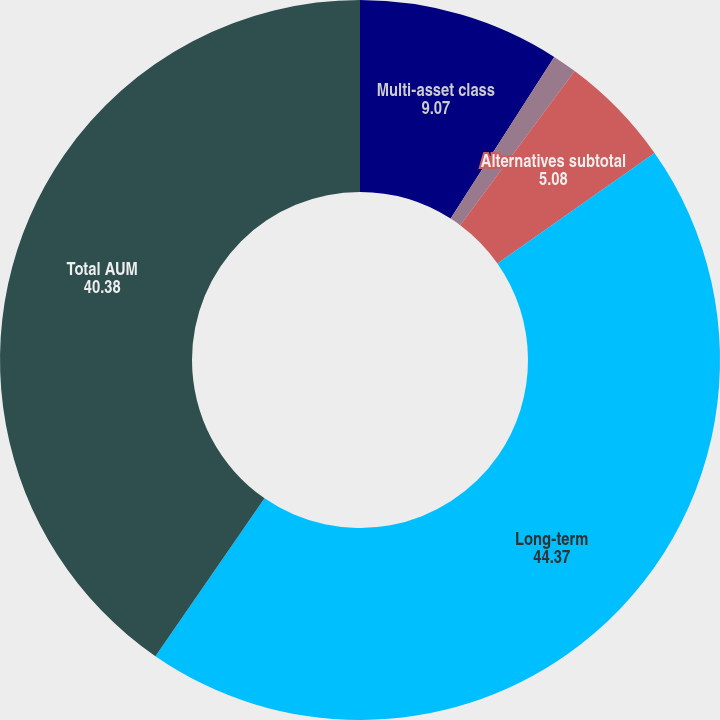<chart> <loc_0><loc_0><loc_500><loc_500><pie_chart><fcel>Multi-asset class<fcel>Core<fcel>Alternatives subtotal<fcel>Long-term<fcel>Total AUM<nl><fcel>9.07%<fcel>1.1%<fcel>5.08%<fcel>44.37%<fcel>40.38%<nl></chart> 